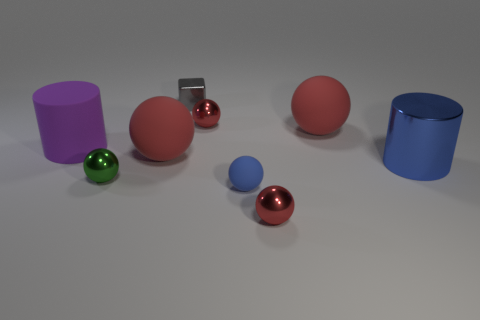There is a metal thing that is the same shape as the large purple matte thing; what is its color?
Ensure brevity in your answer.  Blue. How many tiny metal balls are the same color as the large metallic thing?
Provide a succinct answer. 0. Is there anything else that is the same shape as the gray metallic thing?
Your answer should be very brief. No. There is a tiny red metal thing in front of the large matte thing that is on the right side of the tiny gray metallic thing; is there a big purple thing that is to the right of it?
Ensure brevity in your answer.  No. What number of other tiny objects have the same material as the purple thing?
Ensure brevity in your answer.  1. Do the metal object to the left of the block and the red metal thing in front of the blue cylinder have the same size?
Offer a terse response. Yes. There is a cylinder that is behind the big cylinder that is in front of the big ball that is on the left side of the small gray cube; what is its color?
Your response must be concise. Purple. Are there any small blue shiny objects that have the same shape as the small gray shiny thing?
Make the answer very short. No. Is the number of red balls on the left side of the small matte ball the same as the number of tiny green metal balls left of the big purple rubber object?
Give a very brief answer. No. Is the shape of the large red thing left of the gray shiny thing the same as  the gray shiny object?
Your answer should be compact. No. 